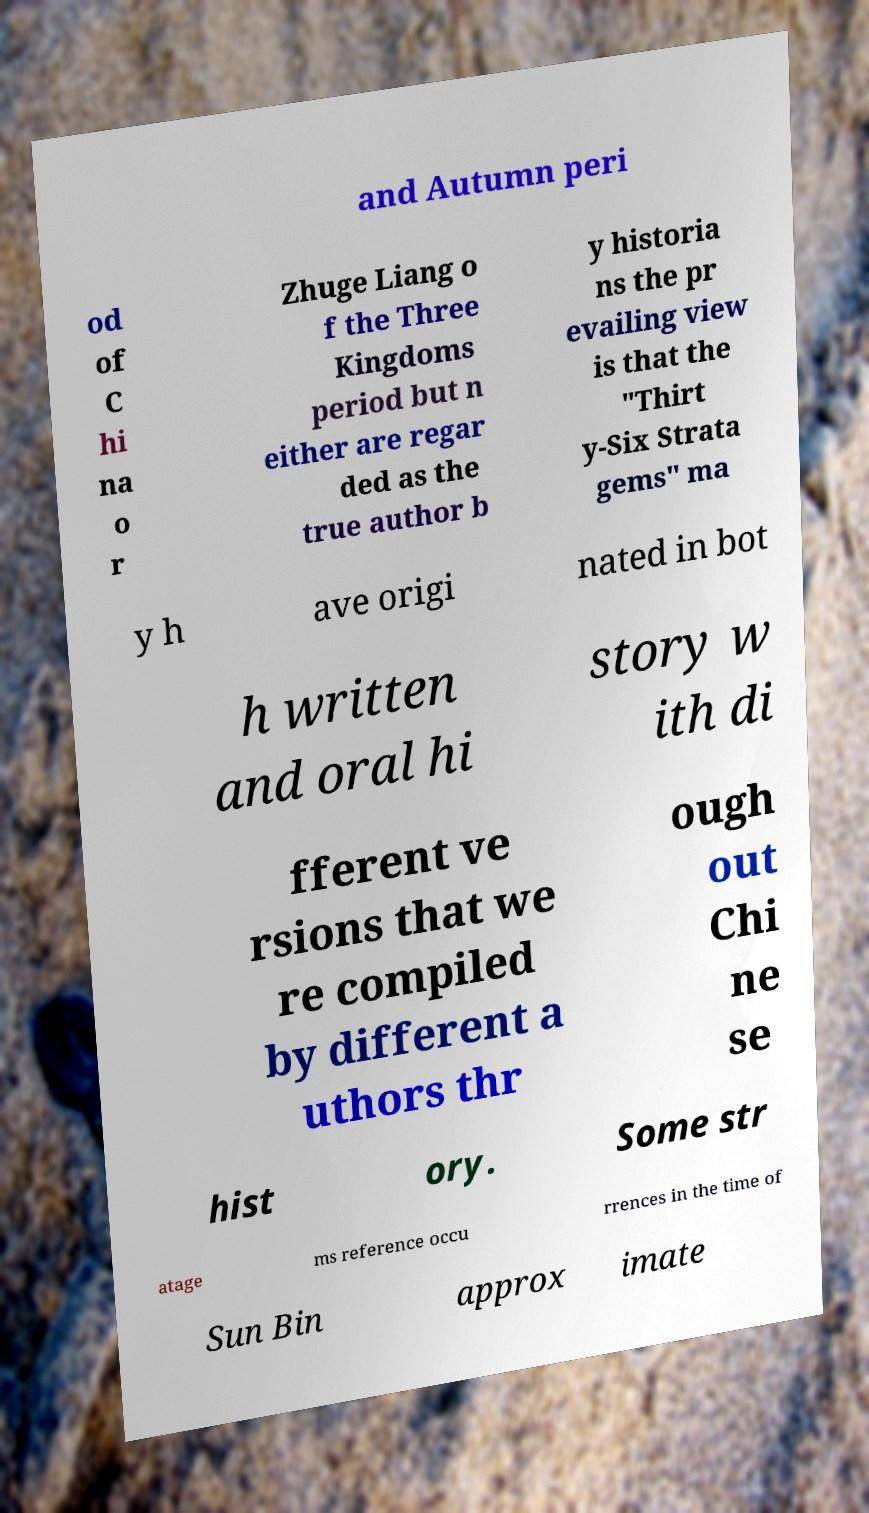Please read and relay the text visible in this image. What does it say? and Autumn peri od of C hi na o r Zhuge Liang o f the Three Kingdoms period but n either are regar ded as the true author b y historia ns the pr evailing view is that the "Thirt y-Six Strata gems" ma y h ave origi nated in bot h written and oral hi story w ith di fferent ve rsions that we re compiled by different a uthors thr ough out Chi ne se hist ory. Some str atage ms reference occu rrences in the time of Sun Bin approx imate 